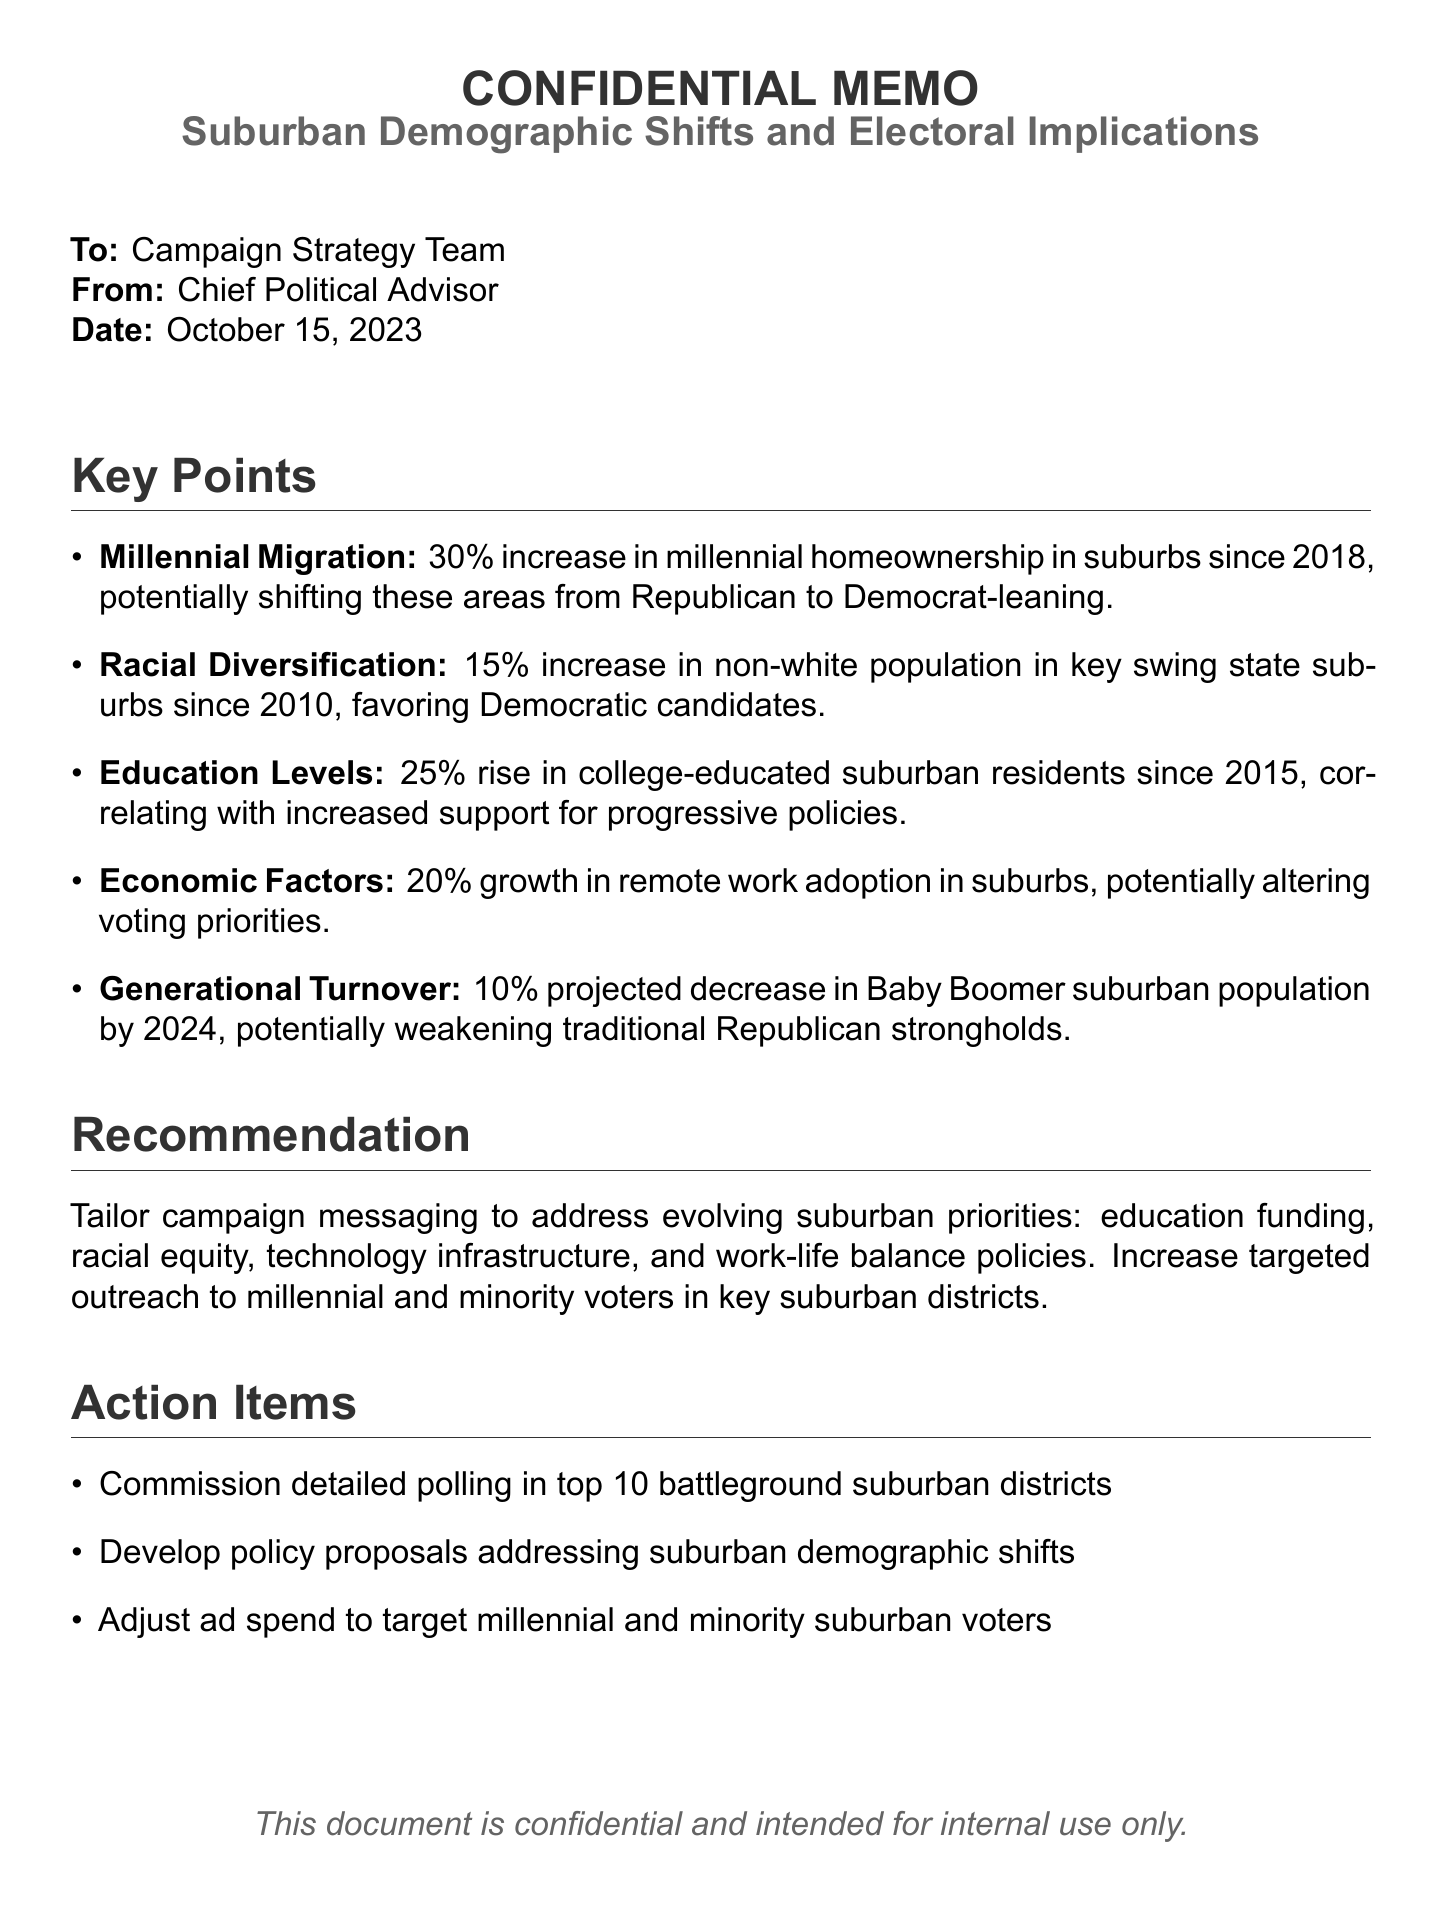what is the increase in millennial homeownership in suburbs since 2018? The document states that there has been a 30% increase in millennial homeownership in suburbs since 2018.
Answer: 30% what is the percentage increase in the non-white population in key swing state suburbs since 2010? The document indicates a 15% increase in the non-white population in these areas since 2010.
Answer: 15% by how much has the number of college-educated suburban residents increased since 2015? The analysis mentions a 25% rise in college-educated suburban residents since 2015.
Answer: 25% what is the projected decrease in Baby Boomer suburban population by 2024? The document projects a 10% decrease in the Baby Boomer suburban population by 2024.
Answer: 10% what is the recommended focus for campaign messaging? The document recommends focusing on education funding, racial equity, technology infrastructure, and work-life balance policies.
Answer: education funding, racial equity, technology infrastructure, work-life balance policies how many battleground suburban districts should be polled? The document suggests commissioning detailed polling in the top 10 battleground suburban districts.
Answer: 10 what trend is associated with a 20% growth in the suburbs? The document associates the 20% growth with remote work adoption in suburbs.
Answer: remote work adoption who is the intended audience of the document? The document is intended for the Campaign Strategy Team.
Answer: Campaign Strategy Team what is the date of the memo? The memo is dated October 15, 2023.
Answer: October 15, 2023 